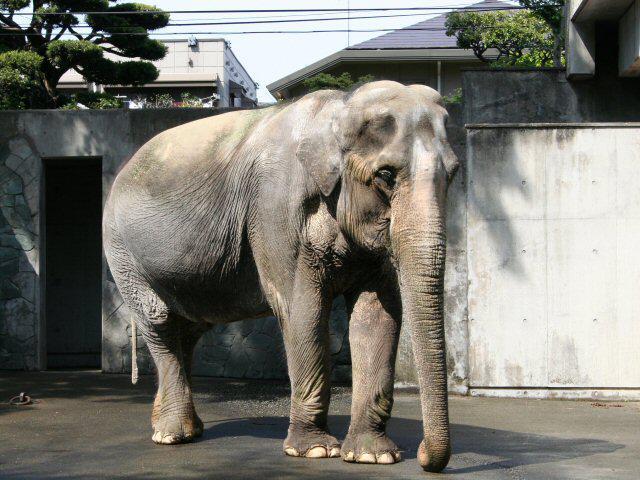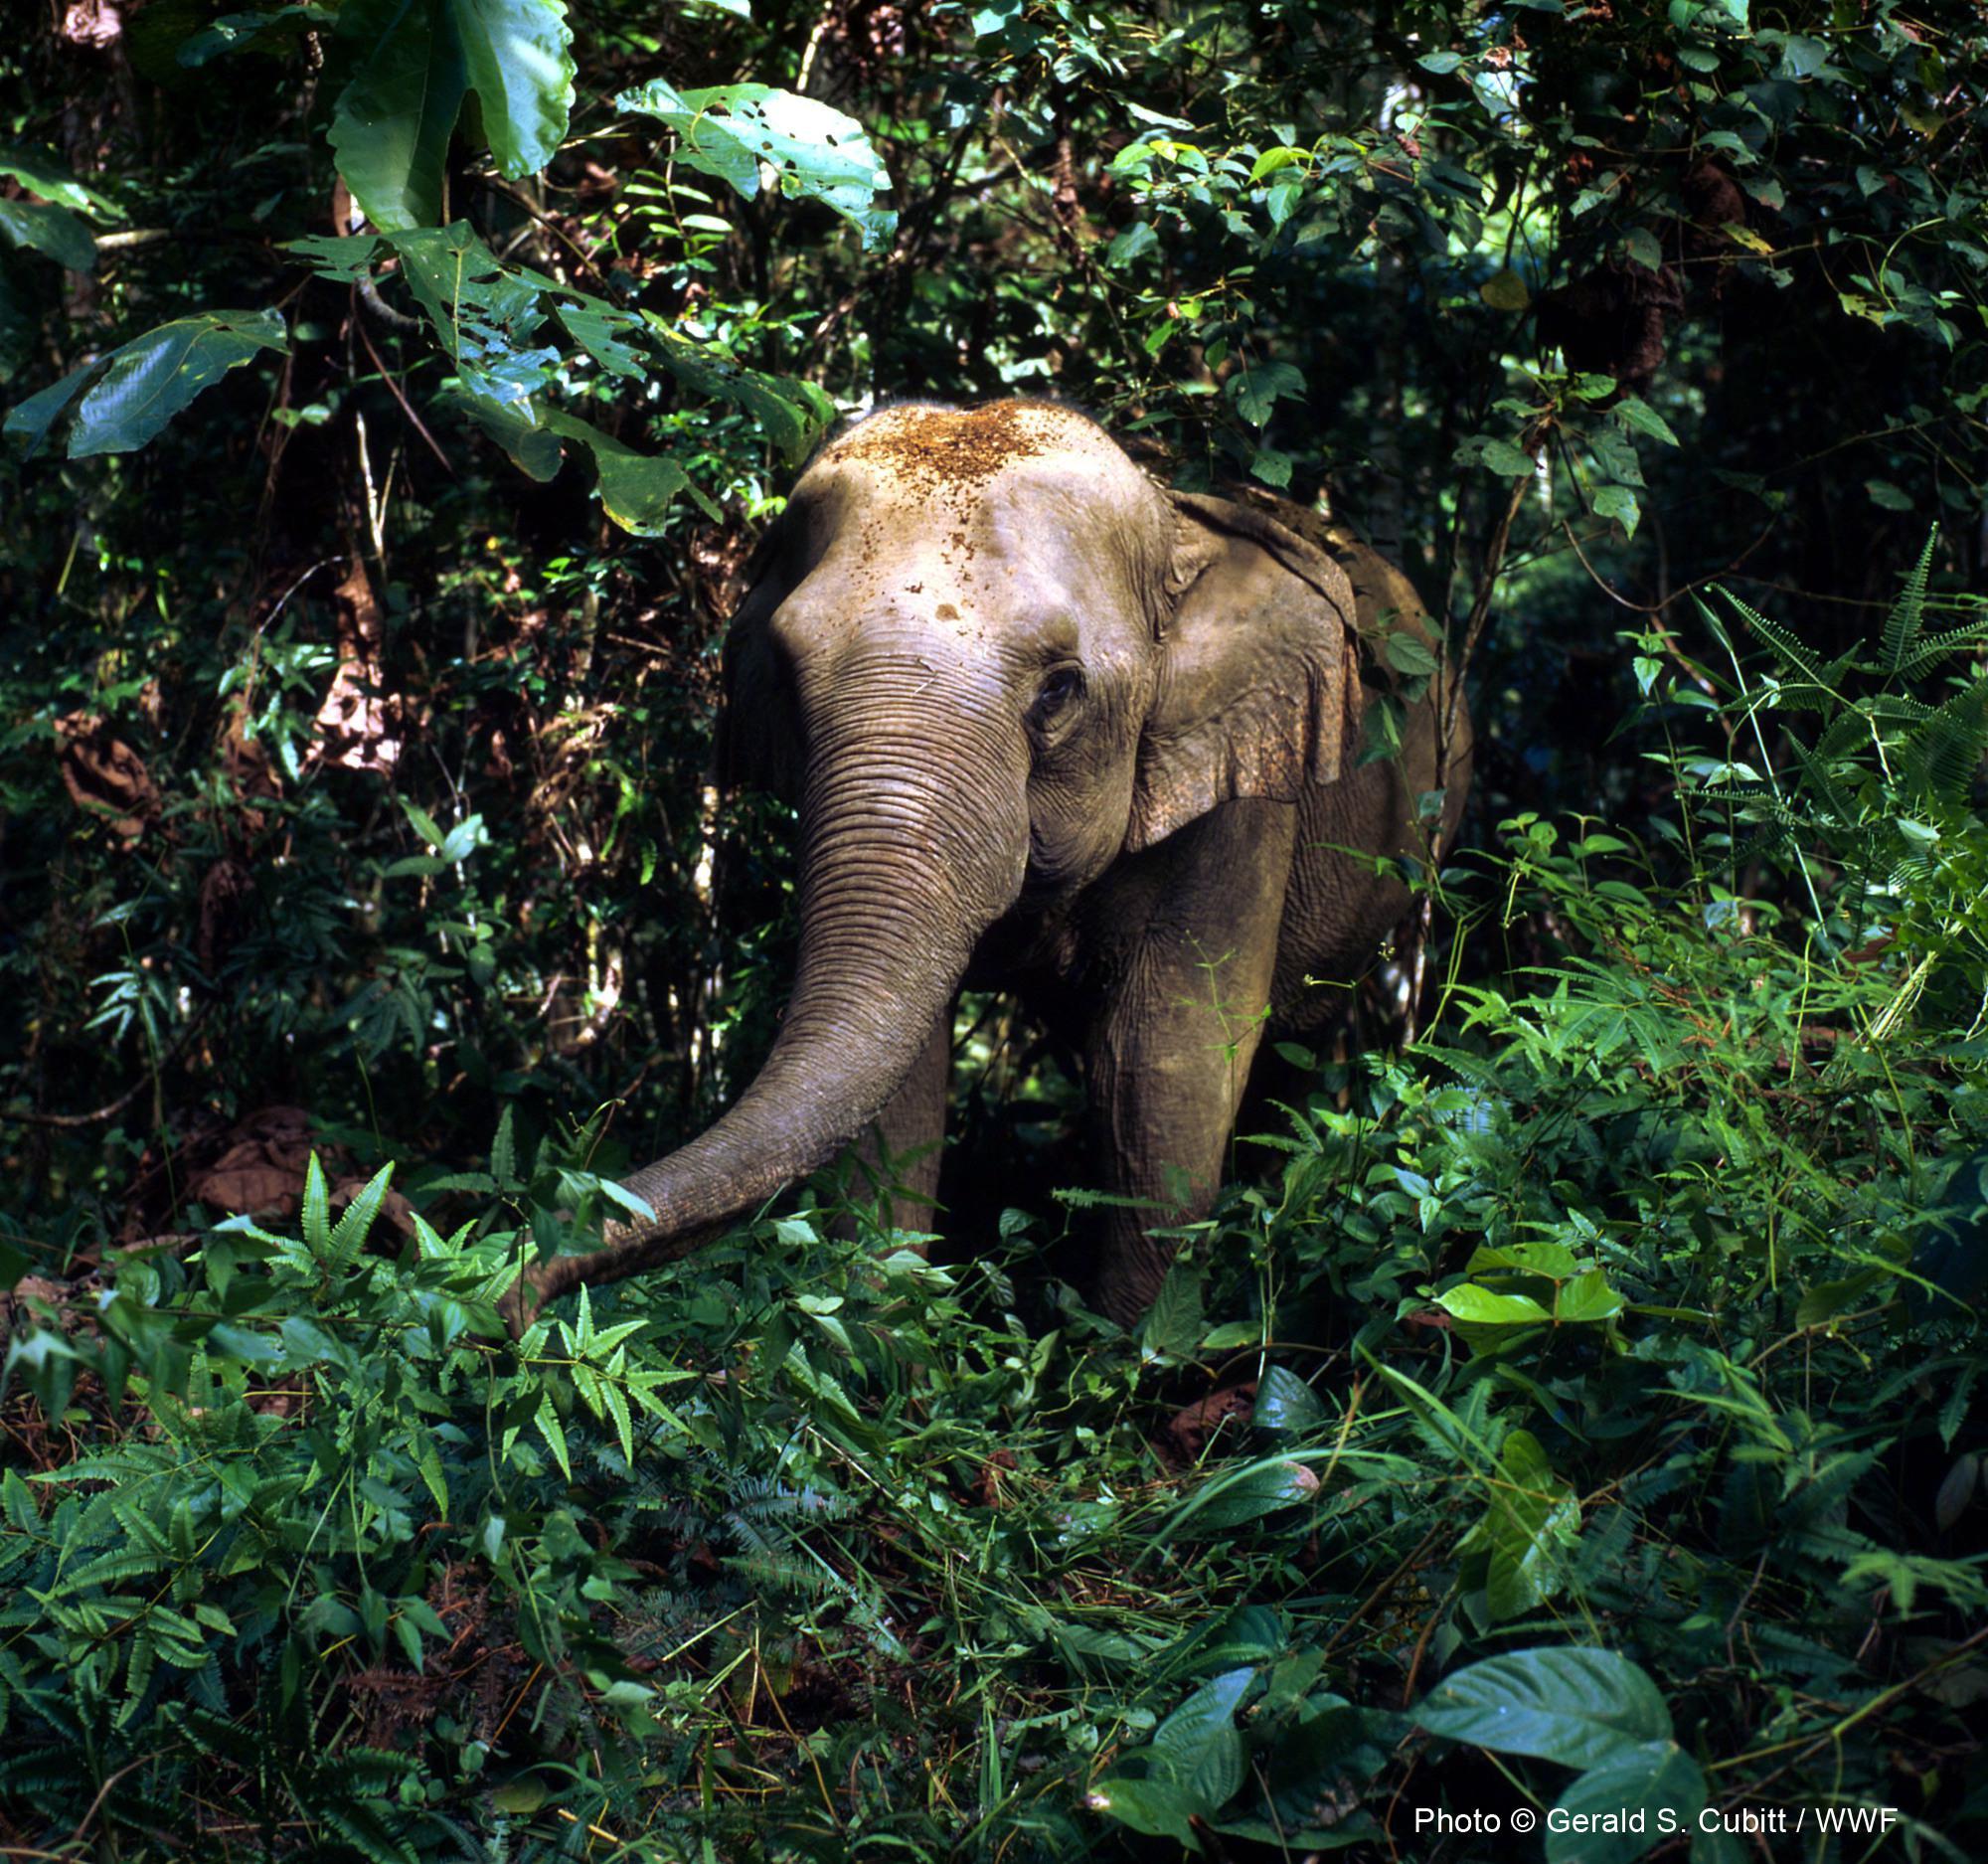The first image is the image on the left, the second image is the image on the right. Analyze the images presented: Is the assertion "In the image to the right, the elephant is right before a tree." valid? Answer yes or no. Yes. 